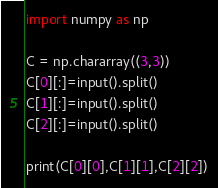<code> <loc_0><loc_0><loc_500><loc_500><_Python_>import numpy as np
 
C = np.chararray((3,3))
C[0][:]=input().split()
C[1][:]=input().split()
C[2][:]=input().split()
 
print(C[0][0],C[1][1],C[2][2])

</code> 